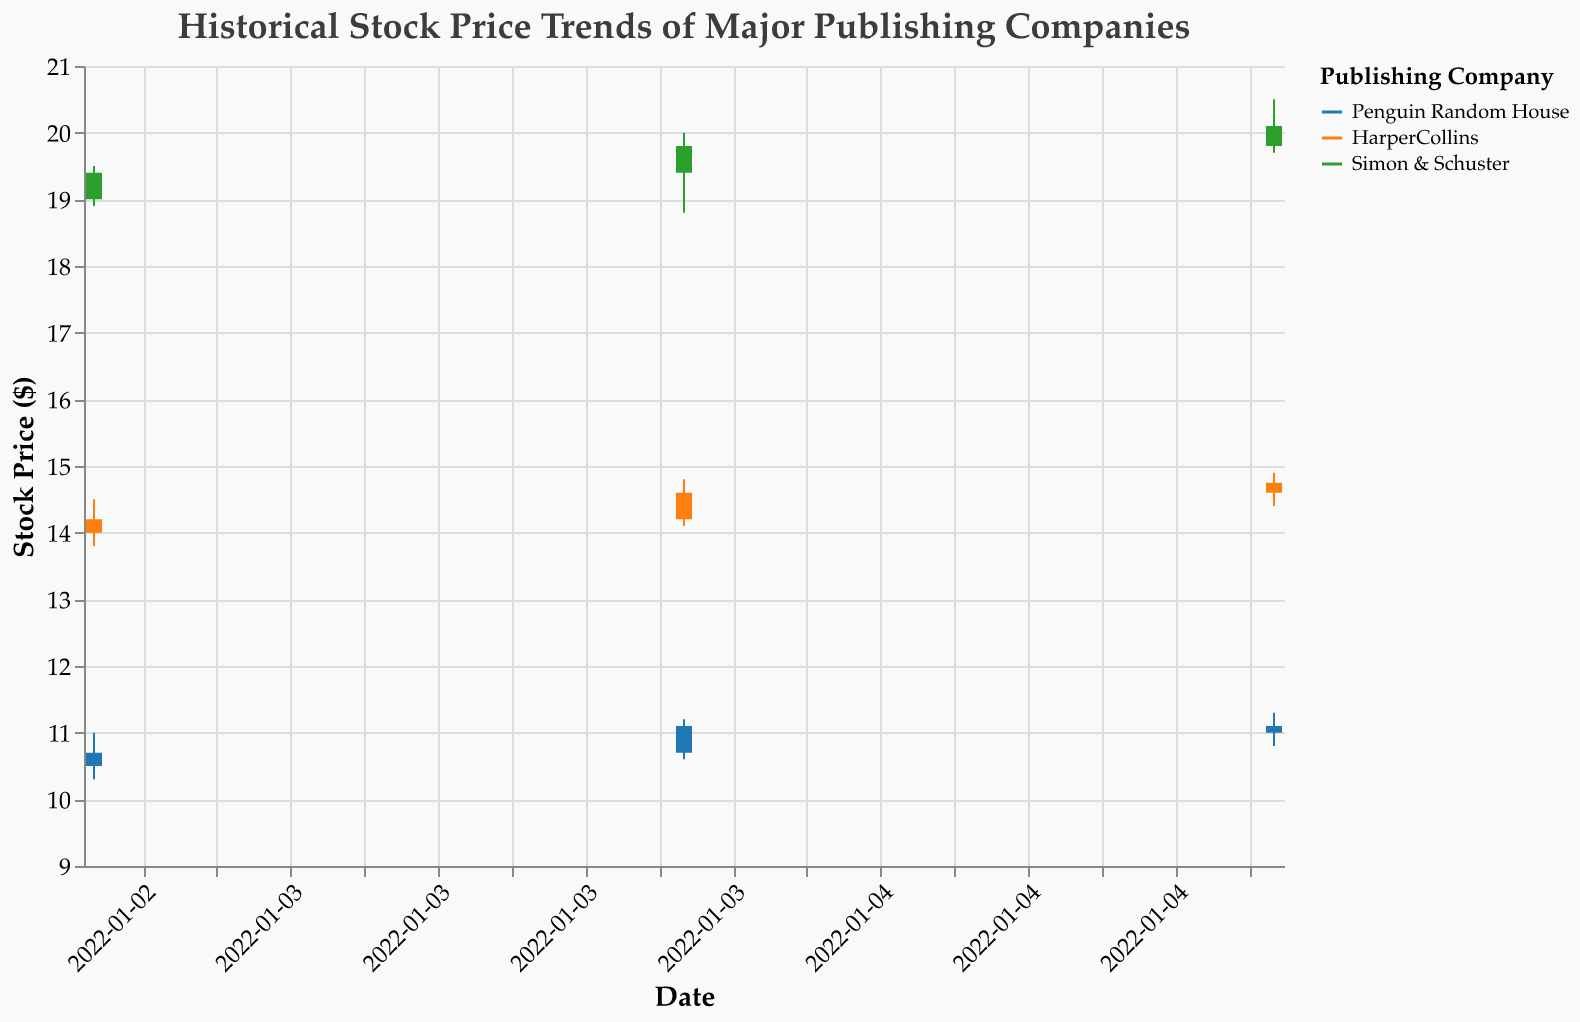What is the highest stock price for Penguin Random House on January 4, 2022? The highest stock price for Penguin Random House on January 4, 2022, corresponds to the "High" value for that date, which is 11.20
Answer: 11.20 Which company had the highest closing price on January 5, 2022? Looking at the "Close" values for January 5, 2022, Simon & Schuster had a closing price of 20.10, which is higher than the others
Answer: Simon & Schuster What is the range (difference between high and low) of HarperCollins stock price on January 3, 2022? The range is calculated by subtracting the "Low" value from the "High" value on January 3, 2022, for HarperCollins: 14.50 - 13.80 = 0.70
Answer: 0.70 Compare the opening prices on January 3, 2022. Which company had the highest opening price? Looking at the "Open" values on January 3, 2022, Simon & Schuster had the highest opening price at 19.00
Answer: Simon & Schuster How did the volume of Penguin Random House stock change from January 4 to January 5, 2022? The volume on January 4 was 1,200,000, and on January 5 it was 1,800,000. The change is 1,800,000 - 1,200,000 = 600,000
Answer: Increased by 600,000 What was the average closing price for HarperCollins over the three days? The average is calculated by summing the "Close" values and dividing by 3: (14.20 + 14.60 + 14.75) / 3 = 14.52
Answer: 14.52 Which company had the most significant increase in closing price from January 3 to January 4, 2022? Penguin Random House increased from 10.70 to 11.10 (0.40), HarperCollins from 14.20 to 14.60 (0.40), Simon & Schuster from 19.40 to 19.80 (0.40). All three companies had the same increase of 0.40
Answer: All companies had the same increase What was the closing price of HarperCollins on January 4, 2022? The closing price for HarperCollins on January 4, 2022, is shown as 14.60
Answer: 14.60 Which company's stock had the lowest price recorded during these dates, and what was the value? The lowest price recorded is the "Low" value, which for Penguin Random House on January 3, 2022, is 10.30
Answer: Penguin Random House, 10.30 